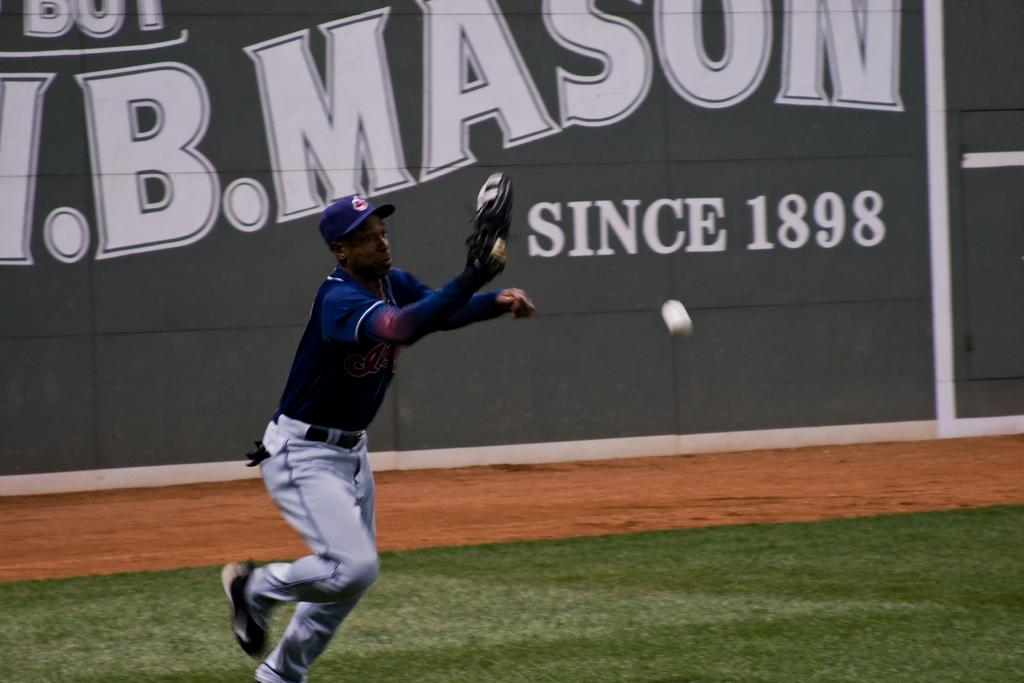<image>
Give a short and clear explanation of the subsequent image. Ball player in front of a wall that has Since 1898 in white. 